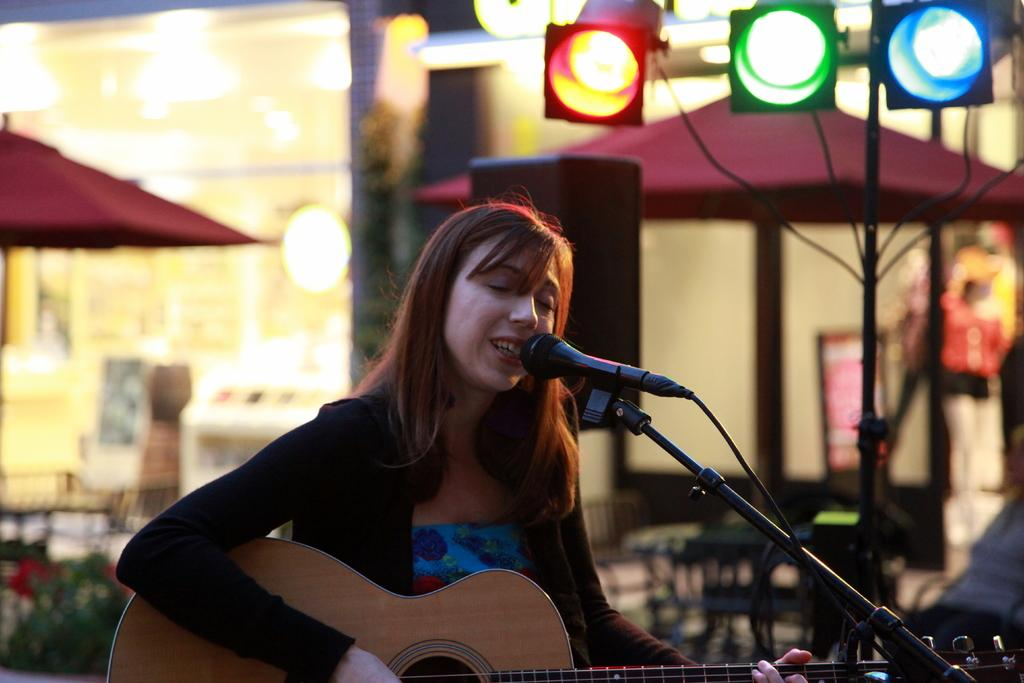What is the woman in the image doing? The woman is playing a guitar and singing. What instrument is the woman using in the image? The woman is playing a guitar. What device is present for amplifying her voice? There is a microphone in the image. What can be seen in the background of the image? There are lights, umbrellas, and a building visible in the background. What type of coal is being used to fuel the woman's performance in the image? There is no coal present in the image, and it does not depict any fuel source for the performance. 